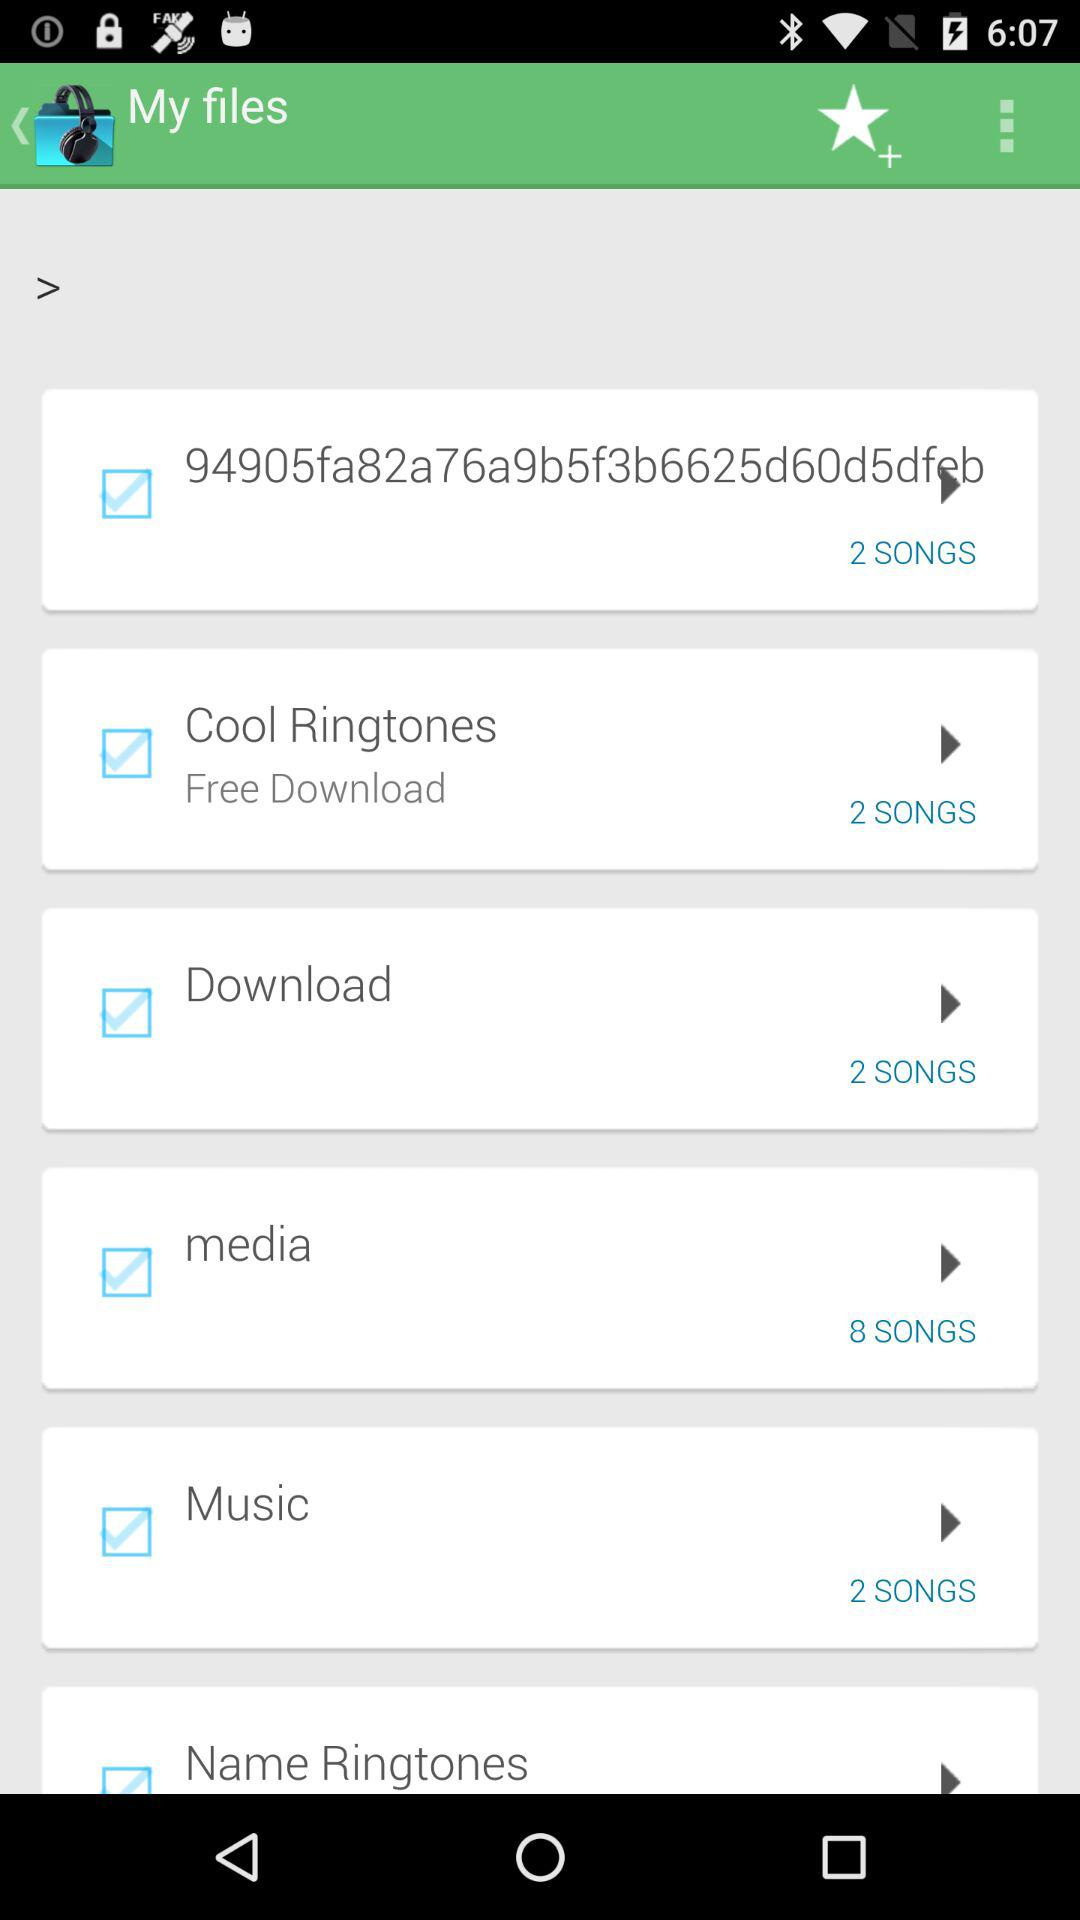How many songs are there in the "media" file? There are 8 songs. 